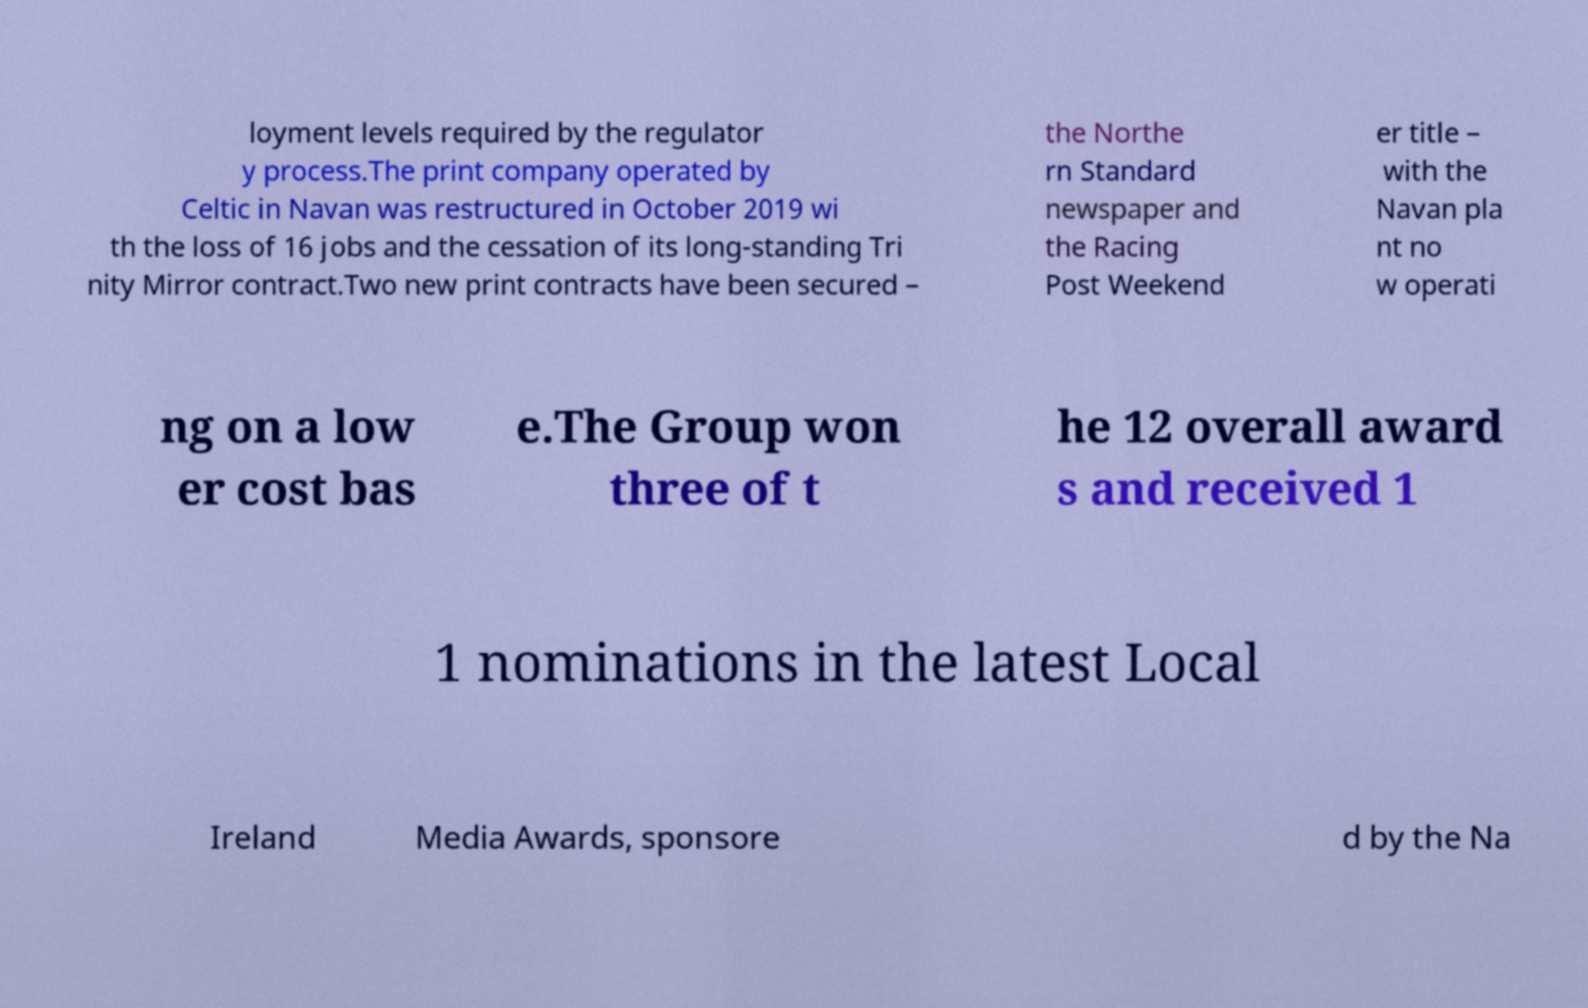I need the written content from this picture converted into text. Can you do that? loyment levels required by the regulator y process.The print company operated by Celtic in Navan was restructured in October 2019 wi th the loss of 16 jobs and the cessation of its long-standing Tri nity Mirror contract.Two new print contracts have been secured – the Northe rn Standard newspaper and the Racing Post Weekend er title – with the Navan pla nt no w operati ng on a low er cost bas e.The Group won three of t he 12 overall award s and received 1 1 nominations in the latest Local Ireland Media Awards, sponsore d by the Na 